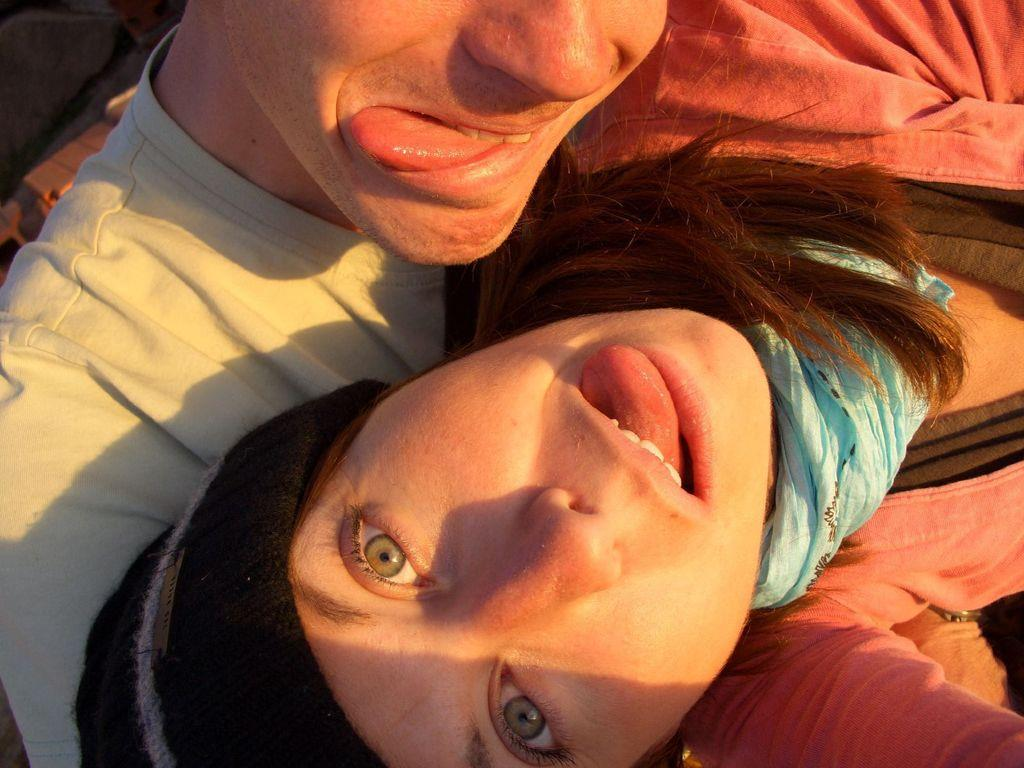How many people are in the image? There are two persons in the image. What are the two persons doing with their tongues? The two persons have their tongues outside. What type of lettuce is being held by the person on the left in the image? There is no lettuce present in the image; both persons have their tongues outside. 